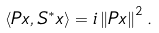<formula> <loc_0><loc_0><loc_500><loc_500>\left \langle P x , S ^ { \ast } x \right \rangle = i \left \| P x \right \| ^ { 2 } .</formula> 